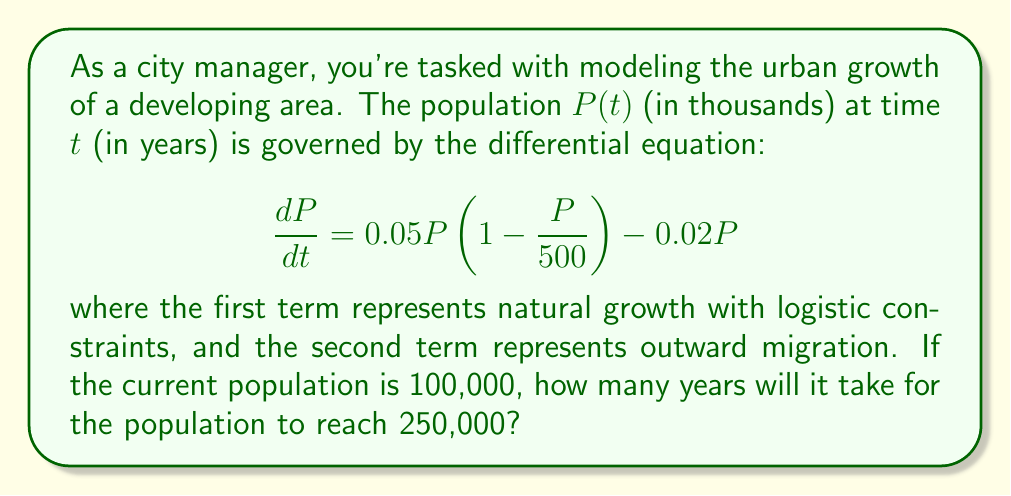Can you answer this question? To solve this problem, we need to follow these steps:

1) First, let's simplify the differential equation:

   $$\frac{dP}{dt} = 0.05P\left(1 - \frac{P}{500}\right) - 0.02P$$
   $$= 0.05P - 0.0001P^2 - 0.02P$$
   $$= 0.03P - 0.0001P^2$$

2) This is a separable differential equation. We can separate the variables:

   $$\frac{dP}{0.03P - 0.0001P^2} = dt$$

3) Integrate both sides:

   $$\int \frac{dP}{0.03P - 0.0001P^2} = \int dt$$

4) The left side can be integrated using partial fractions:

   $$\frac{1}{0.03} \ln\left|\frac{P}{300-P}\right| = t + C$$

5) We can solve for $P$:

   $$P = \frac{300}{1 + Ae^{-0.03t}}$$

   where $A$ is a constant determined by initial conditions.

6) Given $P(0) = 100$, we can find $A$:

   $$100 = \frac{300}{1 + A}$$
   $$A = 2$$

7) So our solution is:

   $$P = \frac{300}{1 + 2e^{-0.03t}}$$

8) To find when $P = 250$, we solve:

   $$250 = \frac{300}{1 + 2e^{-0.03t}}$$

9) Solving for $t$:

   $$1 + 2e^{-0.03t} = \frac{300}{250} = 1.2$$
   $$2e^{-0.03t} = 0.2$$
   $$e^{-0.03t} = 0.1$$
   $$-0.03t = \ln(0.1)$$
   $$t = -\frac{\ln(0.1)}{0.03} \approx 76.86$$
Answer: It will take approximately 76.86 years for the population to reach 250,000. 